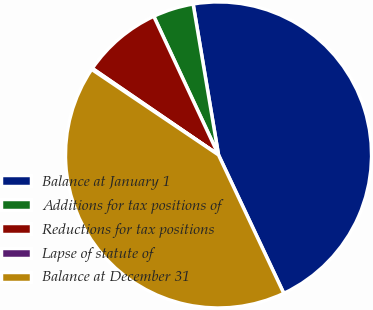Convert chart. <chart><loc_0><loc_0><loc_500><loc_500><pie_chart><fcel>Balance at January 1<fcel>Additions for tax positions of<fcel>Reductions for tax positions<fcel>Lapse of statute of<fcel>Balance at December 31<nl><fcel>45.64%<fcel>4.3%<fcel>8.48%<fcel>0.12%<fcel>41.46%<nl></chart> 